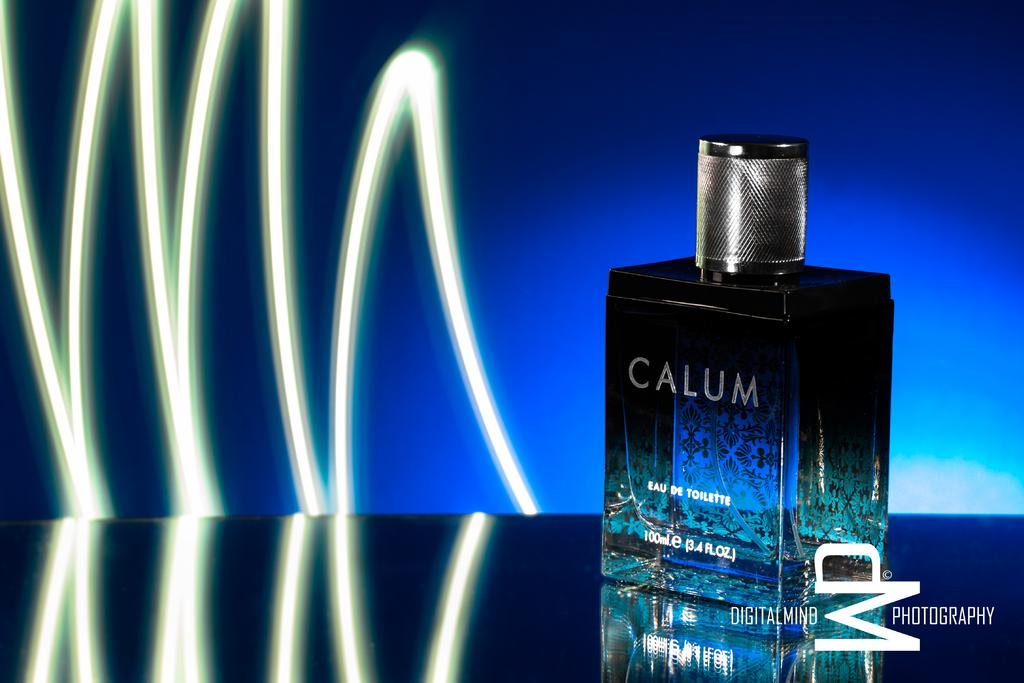<image>
Describe the image concisely. A bottle by Calum sits in front of a blue backround with a white zigzag. 